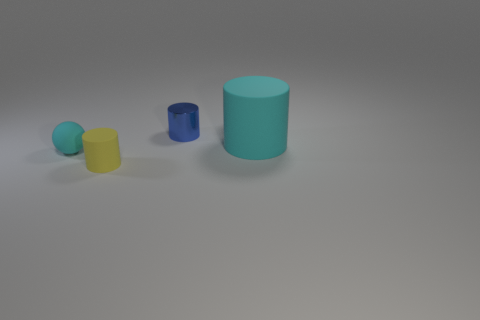Add 1 large gray shiny spheres. How many objects exist? 5 Subtract all spheres. How many objects are left? 3 Add 1 large green metallic balls. How many large green metallic balls exist? 1 Subtract 0 red cylinders. How many objects are left? 4 Subtract all big brown cubes. Subtract all blue metallic objects. How many objects are left? 3 Add 4 spheres. How many spheres are left? 5 